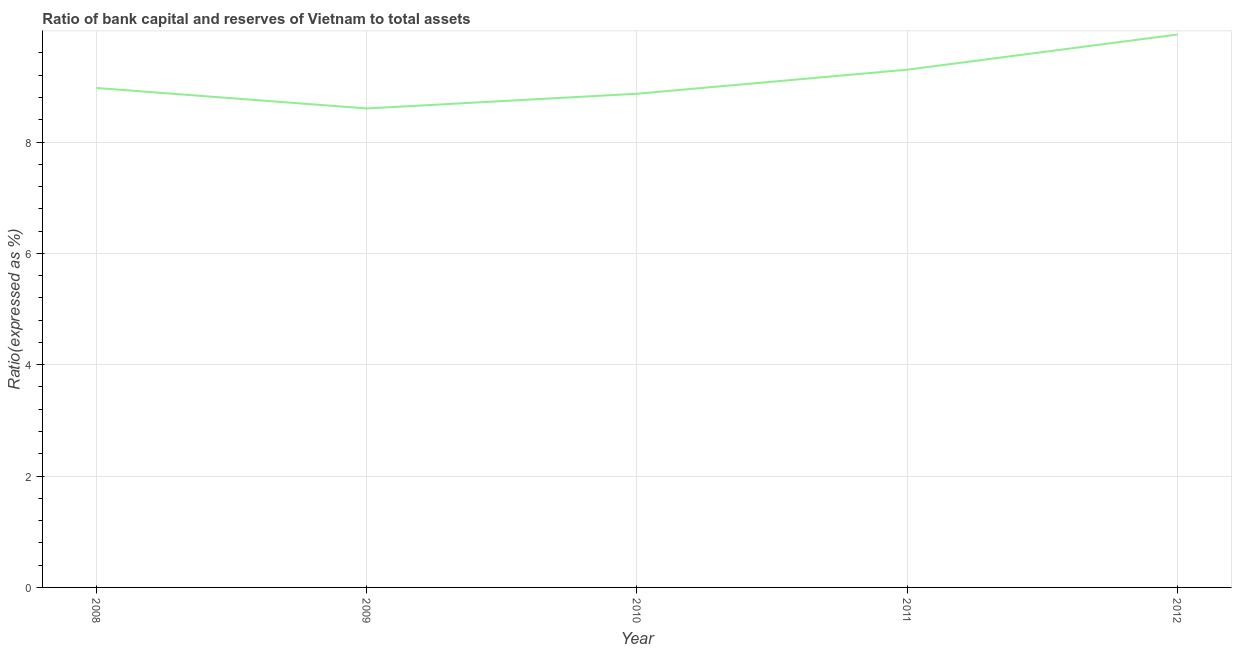What is the bank capital to assets ratio in 2011?
Make the answer very short. 9.3. Across all years, what is the maximum bank capital to assets ratio?
Your answer should be very brief. 9.93. Across all years, what is the minimum bank capital to assets ratio?
Give a very brief answer. 8.6. What is the sum of the bank capital to assets ratio?
Make the answer very short. 45.67. What is the difference between the bank capital to assets ratio in 2009 and 2011?
Make the answer very short. -0.7. What is the average bank capital to assets ratio per year?
Provide a succinct answer. 9.13. What is the median bank capital to assets ratio?
Offer a very short reply. 8.97. In how many years, is the bank capital to assets ratio greater than 3.2 %?
Give a very brief answer. 5. What is the ratio of the bank capital to assets ratio in 2011 to that in 2012?
Offer a terse response. 0.94. Is the difference between the bank capital to assets ratio in 2008 and 2011 greater than the difference between any two years?
Provide a succinct answer. No. What is the difference between the highest and the second highest bank capital to assets ratio?
Your answer should be very brief. 0.63. Is the sum of the bank capital to assets ratio in 2011 and 2012 greater than the maximum bank capital to assets ratio across all years?
Your response must be concise. Yes. What is the difference between the highest and the lowest bank capital to assets ratio?
Your answer should be very brief. 1.33. Does the bank capital to assets ratio monotonically increase over the years?
Ensure brevity in your answer.  No. How many lines are there?
Provide a succinct answer. 1. How many years are there in the graph?
Your answer should be compact. 5. What is the difference between two consecutive major ticks on the Y-axis?
Your answer should be very brief. 2. Does the graph contain grids?
Keep it short and to the point. Yes. What is the title of the graph?
Your response must be concise. Ratio of bank capital and reserves of Vietnam to total assets. What is the label or title of the X-axis?
Ensure brevity in your answer.  Year. What is the label or title of the Y-axis?
Your response must be concise. Ratio(expressed as %). What is the Ratio(expressed as %) of 2008?
Ensure brevity in your answer.  8.97. What is the Ratio(expressed as %) of 2009?
Make the answer very short. 8.6. What is the Ratio(expressed as %) of 2010?
Make the answer very short. 8.87. What is the Ratio(expressed as %) of 2011?
Make the answer very short. 9.3. What is the Ratio(expressed as %) of 2012?
Provide a succinct answer. 9.93. What is the difference between the Ratio(expressed as %) in 2008 and 2009?
Make the answer very short. 0.37. What is the difference between the Ratio(expressed as %) in 2008 and 2010?
Your answer should be compact. 0.1. What is the difference between the Ratio(expressed as %) in 2008 and 2011?
Your response must be concise. -0.33. What is the difference between the Ratio(expressed as %) in 2008 and 2012?
Your answer should be very brief. -0.96. What is the difference between the Ratio(expressed as %) in 2009 and 2010?
Offer a very short reply. -0.26. What is the difference between the Ratio(expressed as %) in 2009 and 2011?
Ensure brevity in your answer.  -0.7. What is the difference between the Ratio(expressed as %) in 2009 and 2012?
Provide a succinct answer. -1.33. What is the difference between the Ratio(expressed as %) in 2010 and 2011?
Your answer should be very brief. -0.43. What is the difference between the Ratio(expressed as %) in 2010 and 2012?
Your answer should be very brief. -1.06. What is the difference between the Ratio(expressed as %) in 2011 and 2012?
Your answer should be very brief. -0.63. What is the ratio of the Ratio(expressed as %) in 2008 to that in 2009?
Your answer should be very brief. 1.04. What is the ratio of the Ratio(expressed as %) in 2008 to that in 2011?
Offer a very short reply. 0.96. What is the ratio of the Ratio(expressed as %) in 2008 to that in 2012?
Your response must be concise. 0.9. What is the ratio of the Ratio(expressed as %) in 2009 to that in 2010?
Ensure brevity in your answer.  0.97. What is the ratio of the Ratio(expressed as %) in 2009 to that in 2011?
Provide a short and direct response. 0.93. What is the ratio of the Ratio(expressed as %) in 2009 to that in 2012?
Provide a short and direct response. 0.87. What is the ratio of the Ratio(expressed as %) in 2010 to that in 2011?
Your answer should be compact. 0.95. What is the ratio of the Ratio(expressed as %) in 2010 to that in 2012?
Offer a very short reply. 0.89. What is the ratio of the Ratio(expressed as %) in 2011 to that in 2012?
Your response must be concise. 0.94. 